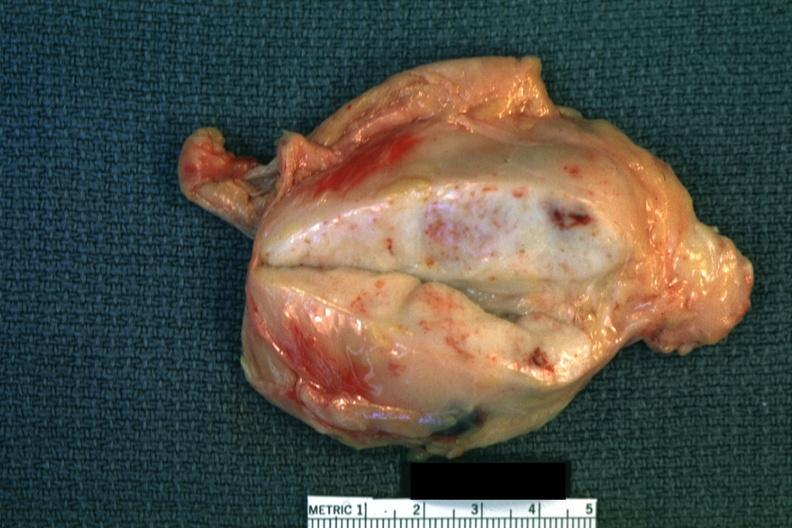what does this image show?
Answer the question using a single word or phrase. Close-up enlarge white node with focal necrosis quite good 